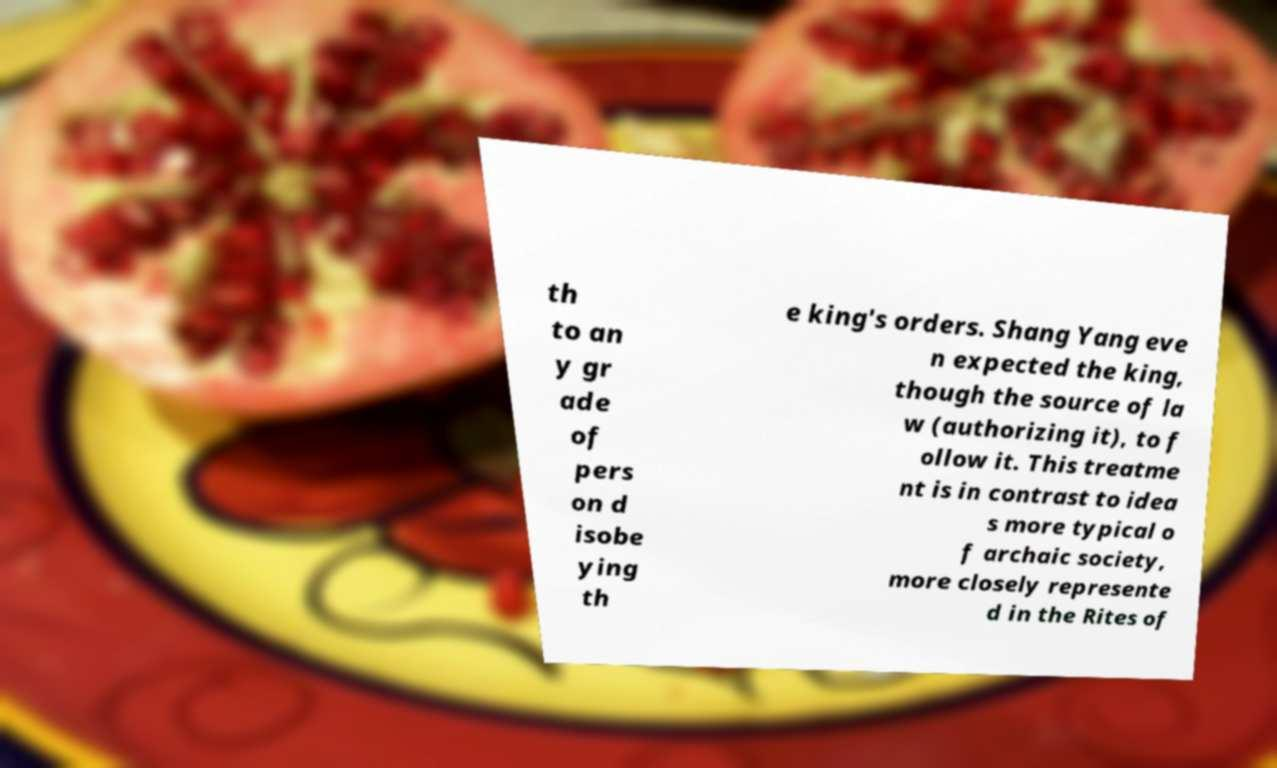Could you assist in decoding the text presented in this image and type it out clearly? th to an y gr ade of pers on d isobe ying th e king's orders. Shang Yang eve n expected the king, though the source of la w (authorizing it), to f ollow it. This treatme nt is in contrast to idea s more typical o f archaic society, more closely represente d in the Rites of 